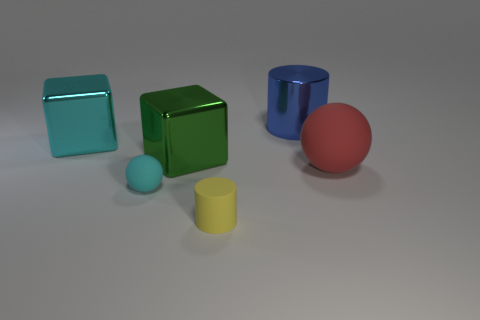There is a rubber object to the right of the cylinder that is in front of the cylinder behind the large matte object; what color is it?
Your response must be concise. Red. There is a small ball in front of the green metallic cube; what color is it?
Offer a terse response. Cyan. What is the color of the cylinder that is the same size as the green thing?
Your answer should be very brief. Blue. Do the yellow matte cylinder and the cyan rubber ball have the same size?
Provide a succinct answer. Yes. What number of cylinders are in front of the big blue shiny thing?
Offer a terse response. 1. How many things are cylinders on the left side of the big shiny cylinder or tiny matte cubes?
Offer a terse response. 1. Are there more blue cylinders on the right side of the tiny cyan matte ball than green objects left of the big green object?
Offer a very short reply. Yes. There is a metal cube that is the same color as the small ball; what is its size?
Keep it short and to the point. Large. There is a blue cylinder; is its size the same as the green metal object that is behind the tiny sphere?
Provide a succinct answer. Yes. How many cylinders are either big blue rubber objects or small yellow matte objects?
Provide a short and direct response. 1. 